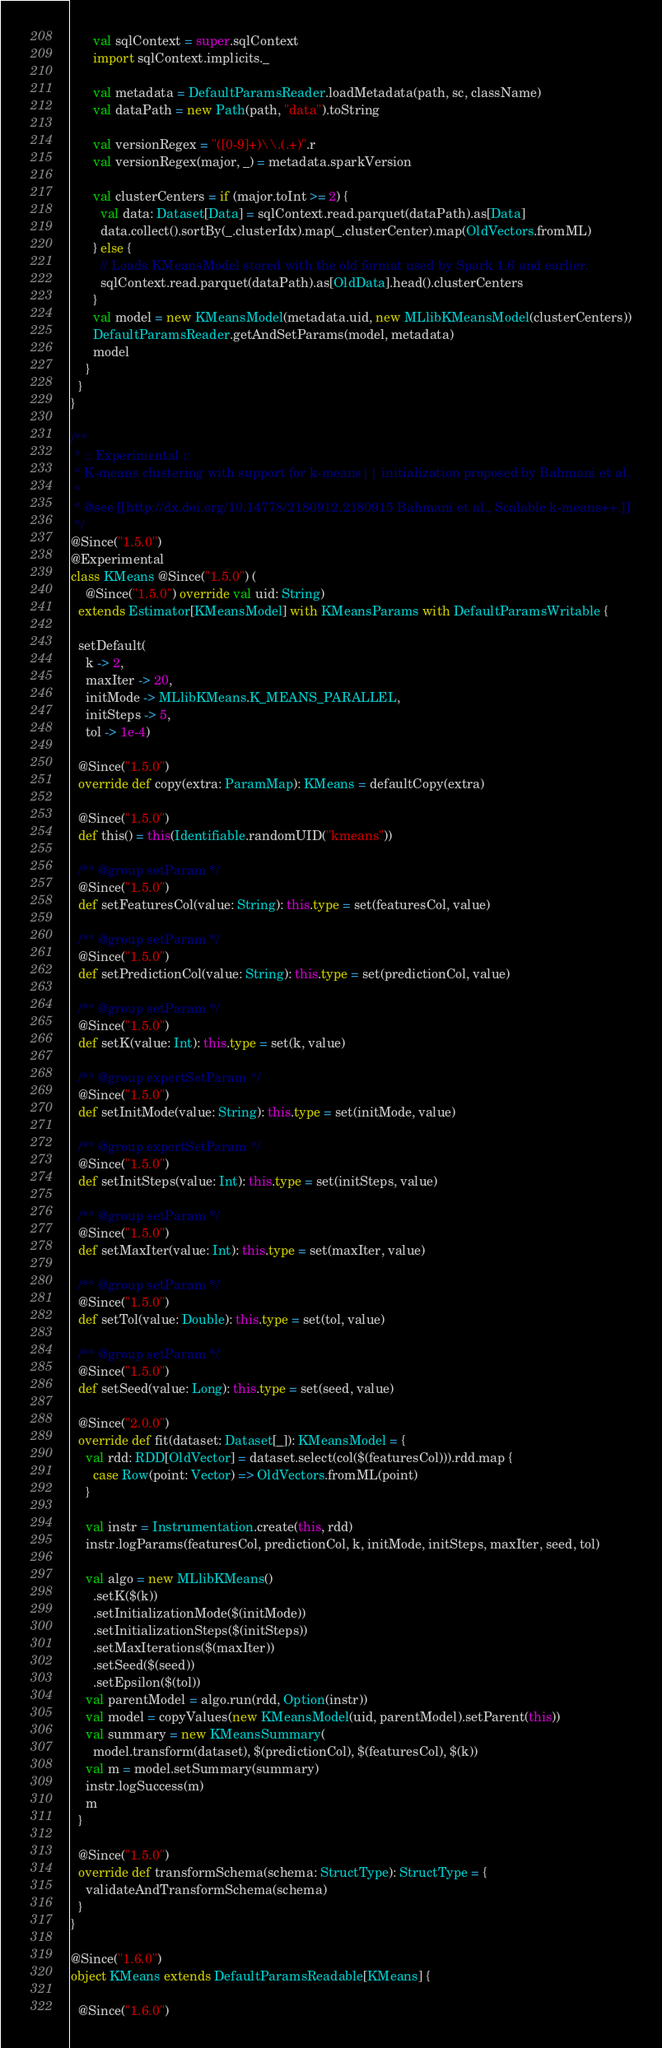Convert code to text. <code><loc_0><loc_0><loc_500><loc_500><_Scala_>      val sqlContext = super.sqlContext
      import sqlContext.implicits._

      val metadata = DefaultParamsReader.loadMetadata(path, sc, className)
      val dataPath = new Path(path, "data").toString

      val versionRegex = "([0-9]+)\\.(.+)".r
      val versionRegex(major, _) = metadata.sparkVersion

      val clusterCenters = if (major.toInt >= 2) {
        val data: Dataset[Data] = sqlContext.read.parquet(dataPath).as[Data]
        data.collect().sortBy(_.clusterIdx).map(_.clusterCenter).map(OldVectors.fromML)
      } else {
        // Loads KMeansModel stored with the old format used by Spark 1.6 and earlier.
        sqlContext.read.parquet(dataPath).as[OldData].head().clusterCenters
      }
      val model = new KMeansModel(metadata.uid, new MLlibKMeansModel(clusterCenters))
      DefaultParamsReader.getAndSetParams(model, metadata)
      model
    }
  }
}

/**
 * :: Experimental ::
 * K-means clustering with support for k-means|| initialization proposed by Bahmani et al.
 *
 * @see [[http://dx.doi.org/10.14778/2180912.2180915 Bahmani et al., Scalable k-means++.]]
 */
@Since("1.5.0")
@Experimental
class KMeans @Since("1.5.0") (
    @Since("1.5.0") override val uid: String)
  extends Estimator[KMeansModel] with KMeansParams with DefaultParamsWritable {

  setDefault(
    k -> 2,
    maxIter -> 20,
    initMode -> MLlibKMeans.K_MEANS_PARALLEL,
    initSteps -> 5,
    tol -> 1e-4)

  @Since("1.5.0")
  override def copy(extra: ParamMap): KMeans = defaultCopy(extra)

  @Since("1.5.0")
  def this() = this(Identifiable.randomUID("kmeans"))

  /** @group setParam */
  @Since("1.5.0")
  def setFeaturesCol(value: String): this.type = set(featuresCol, value)

  /** @group setParam */
  @Since("1.5.0")
  def setPredictionCol(value: String): this.type = set(predictionCol, value)

  /** @group setParam */
  @Since("1.5.0")
  def setK(value: Int): this.type = set(k, value)

  /** @group expertSetParam */
  @Since("1.5.0")
  def setInitMode(value: String): this.type = set(initMode, value)

  /** @group expertSetParam */
  @Since("1.5.0")
  def setInitSteps(value: Int): this.type = set(initSteps, value)

  /** @group setParam */
  @Since("1.5.0")
  def setMaxIter(value: Int): this.type = set(maxIter, value)

  /** @group setParam */
  @Since("1.5.0")
  def setTol(value: Double): this.type = set(tol, value)

  /** @group setParam */
  @Since("1.5.0")
  def setSeed(value: Long): this.type = set(seed, value)

  @Since("2.0.0")
  override def fit(dataset: Dataset[_]): KMeansModel = {
    val rdd: RDD[OldVector] = dataset.select(col($(featuresCol))).rdd.map {
      case Row(point: Vector) => OldVectors.fromML(point)
    }

    val instr = Instrumentation.create(this, rdd)
    instr.logParams(featuresCol, predictionCol, k, initMode, initSteps, maxIter, seed, tol)

    val algo = new MLlibKMeans()
      .setK($(k))
      .setInitializationMode($(initMode))
      .setInitializationSteps($(initSteps))
      .setMaxIterations($(maxIter))
      .setSeed($(seed))
      .setEpsilon($(tol))
    val parentModel = algo.run(rdd, Option(instr))
    val model = copyValues(new KMeansModel(uid, parentModel).setParent(this))
    val summary = new KMeansSummary(
      model.transform(dataset), $(predictionCol), $(featuresCol), $(k))
    val m = model.setSummary(summary)
    instr.logSuccess(m)
    m
  }

  @Since("1.5.0")
  override def transformSchema(schema: StructType): StructType = {
    validateAndTransformSchema(schema)
  }
}

@Since("1.6.0")
object KMeans extends DefaultParamsReadable[KMeans] {

  @Since("1.6.0")</code> 